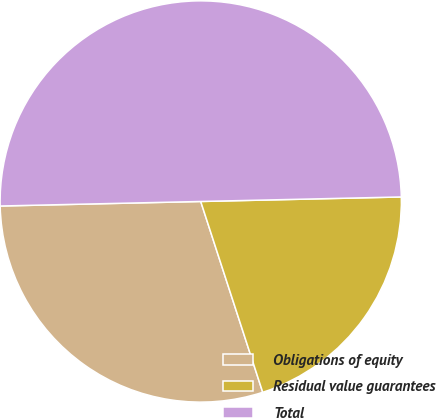<chart> <loc_0><loc_0><loc_500><loc_500><pie_chart><fcel>Obligations of equity<fcel>Residual value guarantees<fcel>Total<nl><fcel>29.64%<fcel>20.36%<fcel>50.0%<nl></chart> 